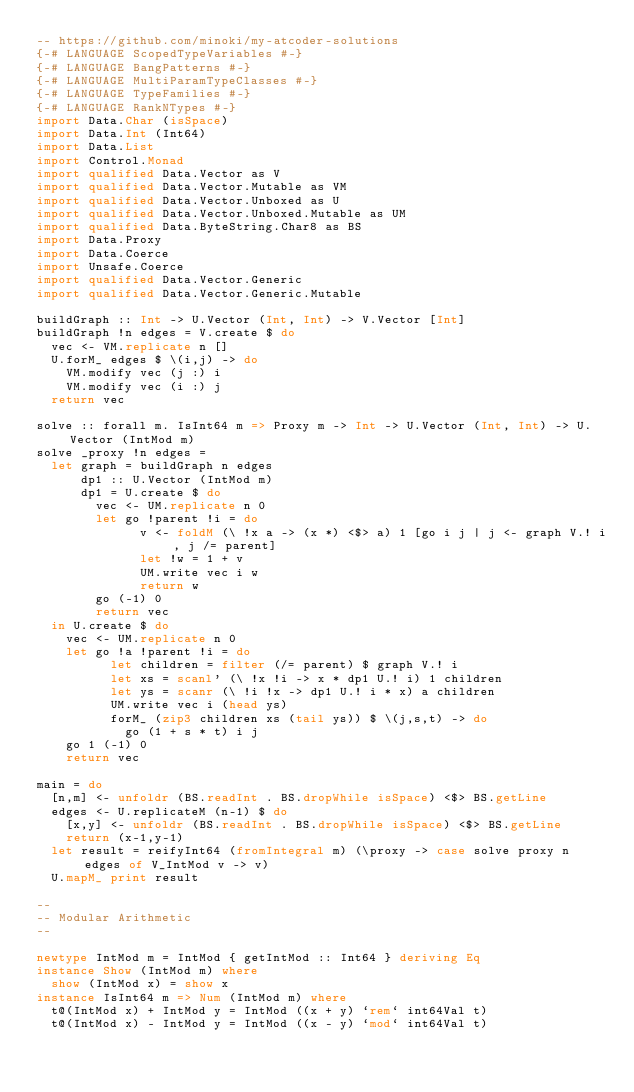<code> <loc_0><loc_0><loc_500><loc_500><_Haskell_>-- https://github.com/minoki/my-atcoder-solutions
{-# LANGUAGE ScopedTypeVariables #-}
{-# LANGUAGE BangPatterns #-}
{-# LANGUAGE MultiParamTypeClasses #-}
{-# LANGUAGE TypeFamilies #-}
{-# LANGUAGE RankNTypes #-}
import Data.Char (isSpace)
import Data.Int (Int64)
import Data.List
import Control.Monad
import qualified Data.Vector as V
import qualified Data.Vector.Mutable as VM
import qualified Data.Vector.Unboxed as U
import qualified Data.Vector.Unboxed.Mutable as UM
import qualified Data.ByteString.Char8 as BS
import Data.Proxy
import Data.Coerce
import Unsafe.Coerce
import qualified Data.Vector.Generic
import qualified Data.Vector.Generic.Mutable

buildGraph :: Int -> U.Vector (Int, Int) -> V.Vector [Int]
buildGraph !n edges = V.create $ do
  vec <- VM.replicate n []
  U.forM_ edges $ \(i,j) -> do
    VM.modify vec (j :) i
    VM.modify vec (i :) j
  return vec

solve :: forall m. IsInt64 m => Proxy m -> Int -> U.Vector (Int, Int) -> U.Vector (IntMod m)
solve _proxy !n edges =
  let graph = buildGraph n edges
      dp1 :: U.Vector (IntMod m)
      dp1 = U.create $ do
        vec <- UM.replicate n 0
        let go !parent !i = do
              v <- foldM (\ !x a -> (x *) <$> a) 1 [go i j | j <- graph V.! i, j /= parent]
              let !w = 1 + v
              UM.write vec i w
              return w
        go (-1) 0
        return vec
  in U.create $ do
    vec <- UM.replicate n 0
    let go !a !parent !i = do
          let children = filter (/= parent) $ graph V.! i
          let xs = scanl' (\ !x !i -> x * dp1 U.! i) 1 children
          let ys = scanr (\ !i !x -> dp1 U.! i * x) a children
          UM.write vec i (head ys)
          forM_ (zip3 children xs (tail ys)) $ \(j,s,t) -> do
            go (1 + s * t) i j
    go 1 (-1) 0
    return vec

main = do
  [n,m] <- unfoldr (BS.readInt . BS.dropWhile isSpace) <$> BS.getLine
  edges <- U.replicateM (n-1) $ do
    [x,y] <- unfoldr (BS.readInt . BS.dropWhile isSpace) <$> BS.getLine
    return (x-1,y-1)
  let result = reifyInt64 (fromIntegral m) (\proxy -> case solve proxy n edges of V_IntMod v -> v)
  U.mapM_ print result

--
-- Modular Arithmetic
--

newtype IntMod m = IntMod { getIntMod :: Int64 } deriving Eq
instance Show (IntMod m) where
  show (IntMod x) = show x
instance IsInt64 m => Num (IntMod m) where
  t@(IntMod x) + IntMod y = IntMod ((x + y) `rem` int64Val t)
  t@(IntMod x) - IntMod y = IntMod ((x - y) `mod` int64Val t)</code> 